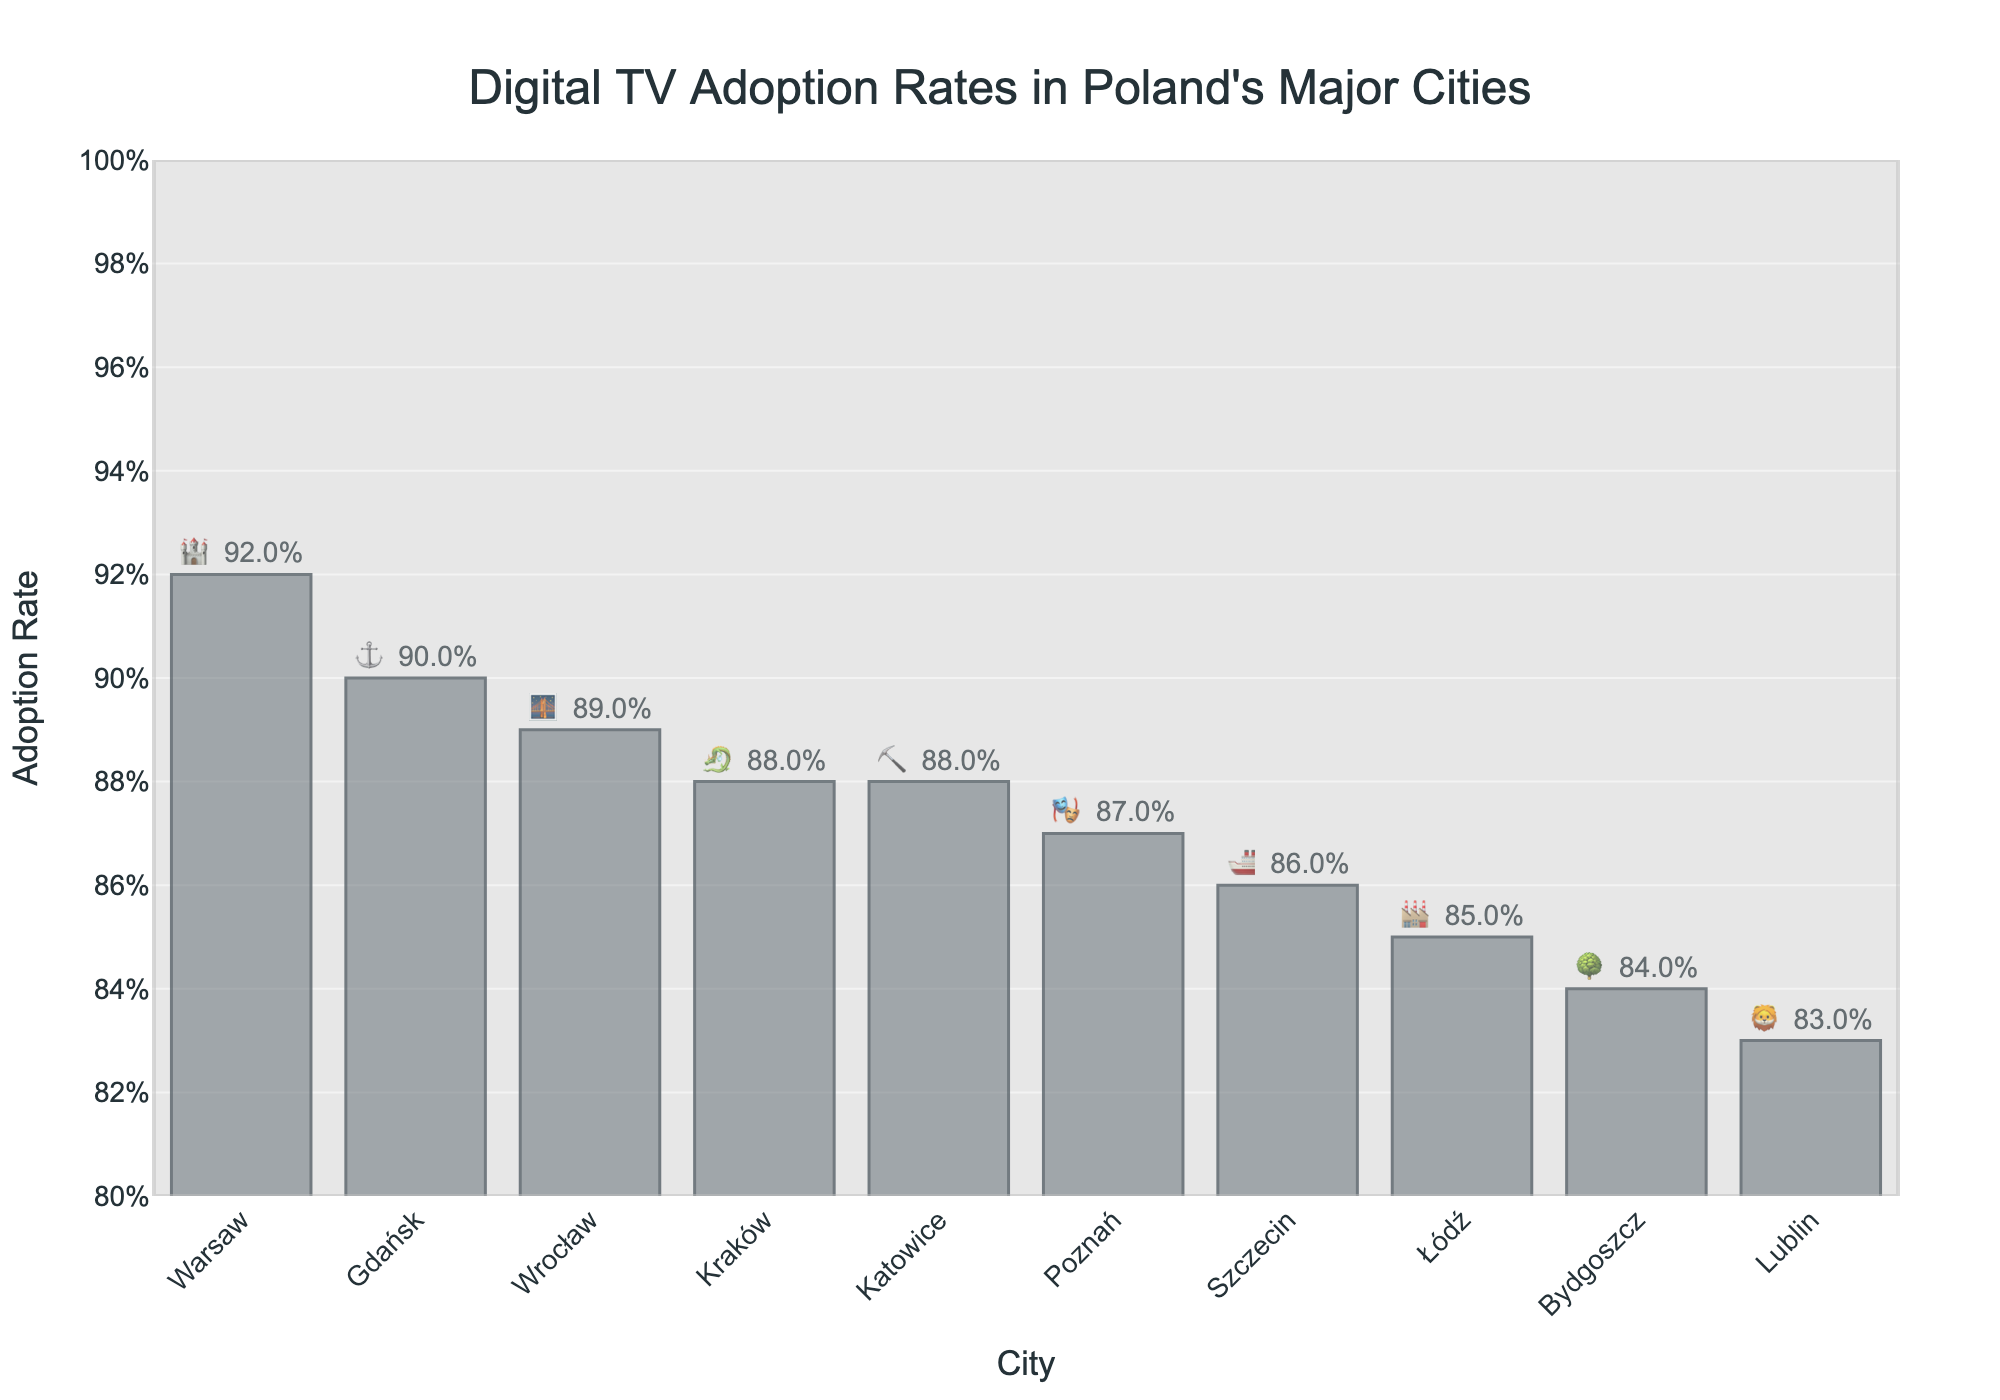What's the city with the highest Digital TV adoption rate and its emoji? To find the city with the highest adoption rate, look for the bar with the highest length. The text beside the bar will indicate the city and its corresponding emoji. Warsaw has the highest rate at 92% with the emoji 🏰.
Answer: Warsaw, 🏰 What's the difference in adoption rates between the cities with the highest and the lowest rates? The highest adoption rate is Warsaw (92%), and the lowest is Lublin (83%). To find the difference, subtract the lowest rate from the highest rate: 92% - 83% = 9%.
Answer: 9% Which city has an adoption rate of 85% and how is it represented in the plot? Look for the bar with text indicating 85% and note the associated city and emoji. Łódź is the city with an 85% adoption rate and is represented by the emoji 🏭.
Answer: Łódź, 🏭 What is the average Digital TV adoption rate across all listed cities? Sum the adoption rates of all cities and divide by the number of cities. The rates are: 92%, 88%, 85%, 89%, 87%, 90%, 86%, 84%, 83%, and 88%. The sum is 872%, and there are 10 cities. Dividing the sum by the number of cities: 872% / 10 = 87.2%.
Answer: 87.2% Which two cities have the same adoption rate, and what is that rate? Look for cities with the same length of bars and text indicating the same percentage. Kraków and Katowice both have an adoption rate of 88% and are represented by 🐉 and ⛏️ respectively.
Answer: Kraków & Katowice, 88% How many cities have a Digital TV adoption rate of 86% or higher? Count the number of bars with text indicating 86% or higher. These cities are Warsaw, Kraków, Łódź, Wrocław, Poznań, Gdańsk, and Szczecin. There are 7 such cities.
Answer: 7 In the plot, what percentage of adoption rates are displayed outside the bars rather than inside? All adoption rate percentages are displayed outside the bars, as indicated by the position of the text in the plot.
Answer: 100% What is the median Digital TV adoption rate among the cities, and how is it calculated? To find the median, list the adoption rates in ascending order and find the middle value. The rates in order are: 83%, 84%, 85%, 86%, 87%, 88%, 88%, 89%, 90%, 92%. Since there are 10 cities, the median is the average of the 5th and 6th values: (87% + 88%) / 2 = 87.5%.
Answer: 87.5% 